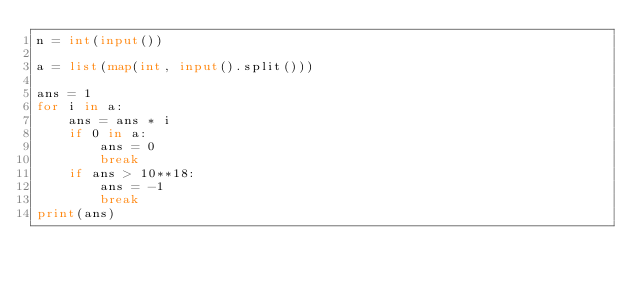<code> <loc_0><loc_0><loc_500><loc_500><_Python_>n = int(input())

a = list(map(int, input().split()))

ans = 1
for i in a:
    ans = ans * i
    if 0 in a:
        ans = 0
        break
    if ans > 10**18:
        ans = -1
        break
print(ans)</code> 